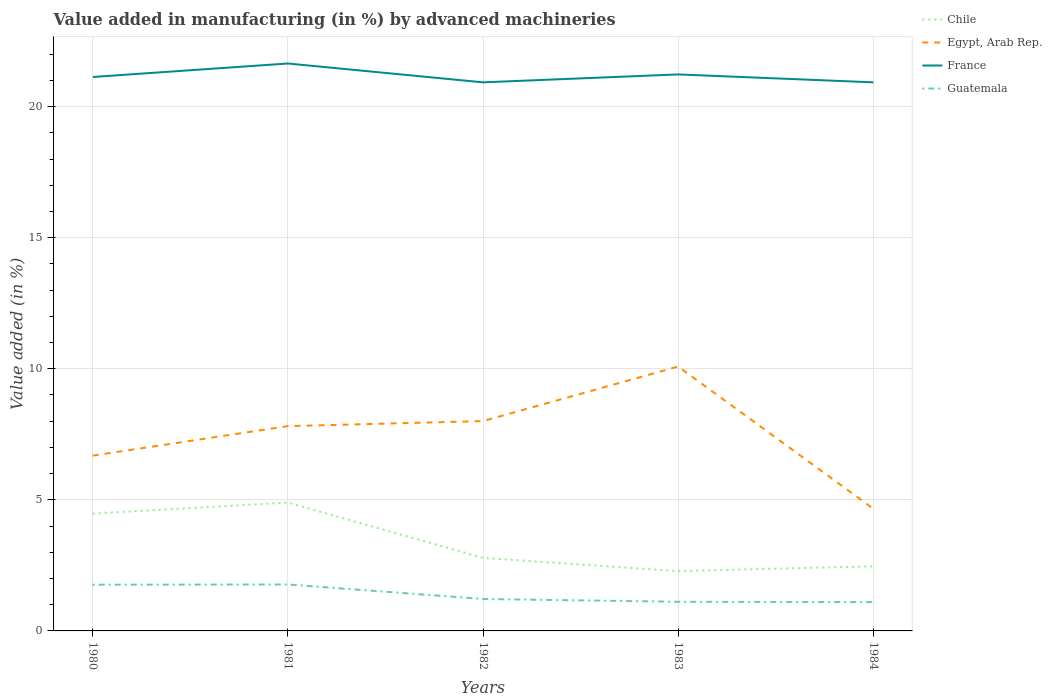How many different coloured lines are there?
Give a very brief answer. 4. Is the number of lines equal to the number of legend labels?
Give a very brief answer. Yes. Across all years, what is the maximum percentage of value added in manufacturing by advanced machineries in Guatemala?
Provide a short and direct response. 1.1. What is the total percentage of value added in manufacturing by advanced machineries in Chile in the graph?
Give a very brief answer. 0.32. What is the difference between the highest and the second highest percentage of value added in manufacturing by advanced machineries in Chile?
Provide a succinct answer. 2.61. How many years are there in the graph?
Give a very brief answer. 5. What is the difference between two consecutive major ticks on the Y-axis?
Keep it short and to the point. 5. Does the graph contain grids?
Your answer should be compact. Yes. How are the legend labels stacked?
Your response must be concise. Vertical. What is the title of the graph?
Your answer should be very brief. Value added in manufacturing (in %) by advanced machineries. What is the label or title of the Y-axis?
Offer a very short reply. Value added (in %). What is the Value added (in %) of Chile in 1980?
Offer a terse response. 4.48. What is the Value added (in %) in Egypt, Arab Rep. in 1980?
Your answer should be very brief. 6.69. What is the Value added (in %) in France in 1980?
Your response must be concise. 21.13. What is the Value added (in %) in Guatemala in 1980?
Give a very brief answer. 1.76. What is the Value added (in %) in Chile in 1981?
Make the answer very short. 4.9. What is the Value added (in %) of Egypt, Arab Rep. in 1981?
Your response must be concise. 7.81. What is the Value added (in %) in France in 1981?
Give a very brief answer. 21.64. What is the Value added (in %) in Guatemala in 1981?
Your response must be concise. 1.77. What is the Value added (in %) of Chile in 1982?
Offer a very short reply. 2.79. What is the Value added (in %) of Egypt, Arab Rep. in 1982?
Make the answer very short. 8. What is the Value added (in %) in France in 1982?
Provide a succinct answer. 20.93. What is the Value added (in %) of Guatemala in 1982?
Make the answer very short. 1.22. What is the Value added (in %) of Chile in 1983?
Your response must be concise. 2.28. What is the Value added (in %) in Egypt, Arab Rep. in 1983?
Make the answer very short. 10.09. What is the Value added (in %) of France in 1983?
Your answer should be very brief. 21.23. What is the Value added (in %) of Guatemala in 1983?
Offer a very short reply. 1.11. What is the Value added (in %) of Chile in 1984?
Give a very brief answer. 2.47. What is the Value added (in %) of Egypt, Arab Rep. in 1984?
Provide a short and direct response. 4.66. What is the Value added (in %) in France in 1984?
Offer a terse response. 20.93. What is the Value added (in %) of Guatemala in 1984?
Keep it short and to the point. 1.1. Across all years, what is the maximum Value added (in %) in Chile?
Your response must be concise. 4.9. Across all years, what is the maximum Value added (in %) of Egypt, Arab Rep.?
Make the answer very short. 10.09. Across all years, what is the maximum Value added (in %) of France?
Provide a short and direct response. 21.64. Across all years, what is the maximum Value added (in %) in Guatemala?
Ensure brevity in your answer.  1.77. Across all years, what is the minimum Value added (in %) of Chile?
Your answer should be compact. 2.28. Across all years, what is the minimum Value added (in %) in Egypt, Arab Rep.?
Make the answer very short. 4.66. Across all years, what is the minimum Value added (in %) of France?
Provide a short and direct response. 20.93. Across all years, what is the minimum Value added (in %) of Guatemala?
Ensure brevity in your answer.  1.1. What is the total Value added (in %) of Chile in the graph?
Offer a terse response. 16.9. What is the total Value added (in %) of Egypt, Arab Rep. in the graph?
Keep it short and to the point. 37.25. What is the total Value added (in %) in France in the graph?
Offer a very short reply. 105.86. What is the total Value added (in %) in Guatemala in the graph?
Make the answer very short. 6.96. What is the difference between the Value added (in %) of Chile in 1980 and that in 1981?
Your answer should be very brief. -0.42. What is the difference between the Value added (in %) in Egypt, Arab Rep. in 1980 and that in 1981?
Offer a very short reply. -1.12. What is the difference between the Value added (in %) in France in 1980 and that in 1981?
Keep it short and to the point. -0.51. What is the difference between the Value added (in %) of Guatemala in 1980 and that in 1981?
Offer a terse response. -0.01. What is the difference between the Value added (in %) in Chile in 1980 and that in 1982?
Keep it short and to the point. 1.69. What is the difference between the Value added (in %) of Egypt, Arab Rep. in 1980 and that in 1982?
Provide a succinct answer. -1.32. What is the difference between the Value added (in %) in France in 1980 and that in 1982?
Provide a succinct answer. 0.2. What is the difference between the Value added (in %) in Guatemala in 1980 and that in 1982?
Make the answer very short. 0.54. What is the difference between the Value added (in %) of Chile in 1980 and that in 1983?
Your answer should be very brief. 2.19. What is the difference between the Value added (in %) in Egypt, Arab Rep. in 1980 and that in 1983?
Provide a short and direct response. -3.4. What is the difference between the Value added (in %) of France in 1980 and that in 1983?
Keep it short and to the point. -0.1. What is the difference between the Value added (in %) in Guatemala in 1980 and that in 1983?
Your answer should be compact. 0.65. What is the difference between the Value added (in %) in Chile in 1980 and that in 1984?
Your response must be concise. 2.01. What is the difference between the Value added (in %) in Egypt, Arab Rep. in 1980 and that in 1984?
Give a very brief answer. 2.02. What is the difference between the Value added (in %) in France in 1980 and that in 1984?
Your response must be concise. 0.2. What is the difference between the Value added (in %) in Guatemala in 1980 and that in 1984?
Your response must be concise. 0.66. What is the difference between the Value added (in %) in Chile in 1981 and that in 1982?
Your answer should be compact. 2.11. What is the difference between the Value added (in %) of Egypt, Arab Rep. in 1981 and that in 1982?
Provide a succinct answer. -0.19. What is the difference between the Value added (in %) of France in 1981 and that in 1982?
Your response must be concise. 0.72. What is the difference between the Value added (in %) of Guatemala in 1981 and that in 1982?
Keep it short and to the point. 0.55. What is the difference between the Value added (in %) in Chile in 1981 and that in 1983?
Ensure brevity in your answer.  2.61. What is the difference between the Value added (in %) in Egypt, Arab Rep. in 1981 and that in 1983?
Give a very brief answer. -2.27. What is the difference between the Value added (in %) of France in 1981 and that in 1983?
Provide a short and direct response. 0.42. What is the difference between the Value added (in %) of Guatemala in 1981 and that in 1983?
Make the answer very short. 0.66. What is the difference between the Value added (in %) of Chile in 1981 and that in 1984?
Your response must be concise. 2.43. What is the difference between the Value added (in %) in Egypt, Arab Rep. in 1981 and that in 1984?
Give a very brief answer. 3.15. What is the difference between the Value added (in %) in France in 1981 and that in 1984?
Your answer should be very brief. 0.72. What is the difference between the Value added (in %) of Guatemala in 1981 and that in 1984?
Your answer should be very brief. 0.67. What is the difference between the Value added (in %) of Chile in 1982 and that in 1983?
Your answer should be compact. 0.51. What is the difference between the Value added (in %) in Egypt, Arab Rep. in 1982 and that in 1983?
Offer a terse response. -2.08. What is the difference between the Value added (in %) of France in 1982 and that in 1983?
Your response must be concise. -0.3. What is the difference between the Value added (in %) in Guatemala in 1982 and that in 1983?
Keep it short and to the point. 0.11. What is the difference between the Value added (in %) of Chile in 1982 and that in 1984?
Provide a succinct answer. 0.32. What is the difference between the Value added (in %) of Egypt, Arab Rep. in 1982 and that in 1984?
Give a very brief answer. 3.34. What is the difference between the Value added (in %) in France in 1982 and that in 1984?
Make the answer very short. -0. What is the difference between the Value added (in %) in Guatemala in 1982 and that in 1984?
Make the answer very short. 0.12. What is the difference between the Value added (in %) in Chile in 1983 and that in 1984?
Keep it short and to the point. -0.18. What is the difference between the Value added (in %) in Egypt, Arab Rep. in 1983 and that in 1984?
Offer a very short reply. 5.42. What is the difference between the Value added (in %) in France in 1983 and that in 1984?
Give a very brief answer. 0.3. What is the difference between the Value added (in %) of Guatemala in 1983 and that in 1984?
Provide a short and direct response. 0.01. What is the difference between the Value added (in %) in Chile in 1980 and the Value added (in %) in Egypt, Arab Rep. in 1981?
Ensure brevity in your answer.  -3.34. What is the difference between the Value added (in %) of Chile in 1980 and the Value added (in %) of France in 1981?
Your answer should be very brief. -17.17. What is the difference between the Value added (in %) of Chile in 1980 and the Value added (in %) of Guatemala in 1981?
Your answer should be very brief. 2.7. What is the difference between the Value added (in %) in Egypt, Arab Rep. in 1980 and the Value added (in %) in France in 1981?
Offer a terse response. -14.96. What is the difference between the Value added (in %) in Egypt, Arab Rep. in 1980 and the Value added (in %) in Guatemala in 1981?
Ensure brevity in your answer.  4.92. What is the difference between the Value added (in %) in France in 1980 and the Value added (in %) in Guatemala in 1981?
Your response must be concise. 19.36. What is the difference between the Value added (in %) of Chile in 1980 and the Value added (in %) of Egypt, Arab Rep. in 1982?
Your answer should be compact. -3.53. What is the difference between the Value added (in %) of Chile in 1980 and the Value added (in %) of France in 1982?
Your response must be concise. -16.45. What is the difference between the Value added (in %) of Chile in 1980 and the Value added (in %) of Guatemala in 1982?
Ensure brevity in your answer.  3.26. What is the difference between the Value added (in %) in Egypt, Arab Rep. in 1980 and the Value added (in %) in France in 1982?
Your answer should be compact. -14.24. What is the difference between the Value added (in %) in Egypt, Arab Rep. in 1980 and the Value added (in %) in Guatemala in 1982?
Give a very brief answer. 5.47. What is the difference between the Value added (in %) of France in 1980 and the Value added (in %) of Guatemala in 1982?
Offer a terse response. 19.91. What is the difference between the Value added (in %) in Chile in 1980 and the Value added (in %) in Egypt, Arab Rep. in 1983?
Your response must be concise. -5.61. What is the difference between the Value added (in %) in Chile in 1980 and the Value added (in %) in France in 1983?
Give a very brief answer. -16.75. What is the difference between the Value added (in %) in Chile in 1980 and the Value added (in %) in Guatemala in 1983?
Offer a very short reply. 3.36. What is the difference between the Value added (in %) in Egypt, Arab Rep. in 1980 and the Value added (in %) in France in 1983?
Offer a terse response. -14.54. What is the difference between the Value added (in %) in Egypt, Arab Rep. in 1980 and the Value added (in %) in Guatemala in 1983?
Give a very brief answer. 5.58. What is the difference between the Value added (in %) in France in 1980 and the Value added (in %) in Guatemala in 1983?
Ensure brevity in your answer.  20.02. What is the difference between the Value added (in %) in Chile in 1980 and the Value added (in %) in Egypt, Arab Rep. in 1984?
Make the answer very short. -0.19. What is the difference between the Value added (in %) of Chile in 1980 and the Value added (in %) of France in 1984?
Provide a succinct answer. -16.45. What is the difference between the Value added (in %) of Chile in 1980 and the Value added (in %) of Guatemala in 1984?
Ensure brevity in your answer.  3.38. What is the difference between the Value added (in %) in Egypt, Arab Rep. in 1980 and the Value added (in %) in France in 1984?
Offer a terse response. -14.24. What is the difference between the Value added (in %) of Egypt, Arab Rep. in 1980 and the Value added (in %) of Guatemala in 1984?
Your answer should be very brief. 5.59. What is the difference between the Value added (in %) in France in 1980 and the Value added (in %) in Guatemala in 1984?
Your response must be concise. 20.03. What is the difference between the Value added (in %) of Chile in 1981 and the Value added (in %) of Egypt, Arab Rep. in 1982?
Your response must be concise. -3.11. What is the difference between the Value added (in %) in Chile in 1981 and the Value added (in %) in France in 1982?
Keep it short and to the point. -16.03. What is the difference between the Value added (in %) in Chile in 1981 and the Value added (in %) in Guatemala in 1982?
Your answer should be very brief. 3.68. What is the difference between the Value added (in %) of Egypt, Arab Rep. in 1981 and the Value added (in %) of France in 1982?
Provide a short and direct response. -13.11. What is the difference between the Value added (in %) of Egypt, Arab Rep. in 1981 and the Value added (in %) of Guatemala in 1982?
Your answer should be compact. 6.59. What is the difference between the Value added (in %) in France in 1981 and the Value added (in %) in Guatemala in 1982?
Make the answer very short. 20.43. What is the difference between the Value added (in %) in Chile in 1981 and the Value added (in %) in Egypt, Arab Rep. in 1983?
Provide a succinct answer. -5.19. What is the difference between the Value added (in %) of Chile in 1981 and the Value added (in %) of France in 1983?
Keep it short and to the point. -16.33. What is the difference between the Value added (in %) in Chile in 1981 and the Value added (in %) in Guatemala in 1983?
Give a very brief answer. 3.78. What is the difference between the Value added (in %) of Egypt, Arab Rep. in 1981 and the Value added (in %) of France in 1983?
Your answer should be very brief. -13.42. What is the difference between the Value added (in %) in Egypt, Arab Rep. in 1981 and the Value added (in %) in Guatemala in 1983?
Offer a very short reply. 6.7. What is the difference between the Value added (in %) of France in 1981 and the Value added (in %) of Guatemala in 1983?
Your answer should be compact. 20.53. What is the difference between the Value added (in %) of Chile in 1981 and the Value added (in %) of Egypt, Arab Rep. in 1984?
Your answer should be very brief. 0.23. What is the difference between the Value added (in %) in Chile in 1981 and the Value added (in %) in France in 1984?
Offer a terse response. -16.03. What is the difference between the Value added (in %) in Chile in 1981 and the Value added (in %) in Guatemala in 1984?
Your answer should be compact. 3.8. What is the difference between the Value added (in %) in Egypt, Arab Rep. in 1981 and the Value added (in %) in France in 1984?
Your response must be concise. -13.11. What is the difference between the Value added (in %) of Egypt, Arab Rep. in 1981 and the Value added (in %) of Guatemala in 1984?
Give a very brief answer. 6.71. What is the difference between the Value added (in %) in France in 1981 and the Value added (in %) in Guatemala in 1984?
Provide a short and direct response. 20.55. What is the difference between the Value added (in %) of Chile in 1982 and the Value added (in %) of Egypt, Arab Rep. in 1983?
Provide a short and direct response. -7.3. What is the difference between the Value added (in %) of Chile in 1982 and the Value added (in %) of France in 1983?
Your answer should be compact. -18.44. What is the difference between the Value added (in %) in Chile in 1982 and the Value added (in %) in Guatemala in 1983?
Offer a terse response. 1.67. What is the difference between the Value added (in %) of Egypt, Arab Rep. in 1982 and the Value added (in %) of France in 1983?
Your response must be concise. -13.22. What is the difference between the Value added (in %) in Egypt, Arab Rep. in 1982 and the Value added (in %) in Guatemala in 1983?
Offer a terse response. 6.89. What is the difference between the Value added (in %) of France in 1982 and the Value added (in %) of Guatemala in 1983?
Ensure brevity in your answer.  19.81. What is the difference between the Value added (in %) in Chile in 1982 and the Value added (in %) in Egypt, Arab Rep. in 1984?
Give a very brief answer. -1.88. What is the difference between the Value added (in %) of Chile in 1982 and the Value added (in %) of France in 1984?
Your answer should be very brief. -18.14. What is the difference between the Value added (in %) of Chile in 1982 and the Value added (in %) of Guatemala in 1984?
Your answer should be compact. 1.69. What is the difference between the Value added (in %) of Egypt, Arab Rep. in 1982 and the Value added (in %) of France in 1984?
Your answer should be compact. -12.92. What is the difference between the Value added (in %) in Egypt, Arab Rep. in 1982 and the Value added (in %) in Guatemala in 1984?
Offer a terse response. 6.9. What is the difference between the Value added (in %) of France in 1982 and the Value added (in %) of Guatemala in 1984?
Give a very brief answer. 19.83. What is the difference between the Value added (in %) in Chile in 1983 and the Value added (in %) in Egypt, Arab Rep. in 1984?
Ensure brevity in your answer.  -2.38. What is the difference between the Value added (in %) in Chile in 1983 and the Value added (in %) in France in 1984?
Make the answer very short. -18.65. What is the difference between the Value added (in %) in Chile in 1983 and the Value added (in %) in Guatemala in 1984?
Your response must be concise. 1.18. What is the difference between the Value added (in %) of Egypt, Arab Rep. in 1983 and the Value added (in %) of France in 1984?
Ensure brevity in your answer.  -10.84. What is the difference between the Value added (in %) in Egypt, Arab Rep. in 1983 and the Value added (in %) in Guatemala in 1984?
Ensure brevity in your answer.  8.99. What is the difference between the Value added (in %) of France in 1983 and the Value added (in %) of Guatemala in 1984?
Offer a very short reply. 20.13. What is the average Value added (in %) of Chile per year?
Keep it short and to the point. 3.38. What is the average Value added (in %) in Egypt, Arab Rep. per year?
Ensure brevity in your answer.  7.45. What is the average Value added (in %) of France per year?
Make the answer very short. 21.17. What is the average Value added (in %) of Guatemala per year?
Your answer should be compact. 1.39. In the year 1980, what is the difference between the Value added (in %) of Chile and Value added (in %) of Egypt, Arab Rep.?
Make the answer very short. -2.21. In the year 1980, what is the difference between the Value added (in %) of Chile and Value added (in %) of France?
Provide a succinct answer. -16.66. In the year 1980, what is the difference between the Value added (in %) of Chile and Value added (in %) of Guatemala?
Offer a very short reply. 2.71. In the year 1980, what is the difference between the Value added (in %) in Egypt, Arab Rep. and Value added (in %) in France?
Offer a terse response. -14.44. In the year 1980, what is the difference between the Value added (in %) of Egypt, Arab Rep. and Value added (in %) of Guatemala?
Make the answer very short. 4.92. In the year 1980, what is the difference between the Value added (in %) of France and Value added (in %) of Guatemala?
Offer a very short reply. 19.37. In the year 1981, what is the difference between the Value added (in %) of Chile and Value added (in %) of Egypt, Arab Rep.?
Your response must be concise. -2.92. In the year 1981, what is the difference between the Value added (in %) in Chile and Value added (in %) in France?
Provide a short and direct response. -16.75. In the year 1981, what is the difference between the Value added (in %) in Chile and Value added (in %) in Guatemala?
Make the answer very short. 3.12. In the year 1981, what is the difference between the Value added (in %) in Egypt, Arab Rep. and Value added (in %) in France?
Provide a short and direct response. -13.83. In the year 1981, what is the difference between the Value added (in %) in Egypt, Arab Rep. and Value added (in %) in Guatemala?
Your answer should be compact. 6.04. In the year 1981, what is the difference between the Value added (in %) in France and Value added (in %) in Guatemala?
Your answer should be very brief. 19.87. In the year 1982, what is the difference between the Value added (in %) in Chile and Value added (in %) in Egypt, Arab Rep.?
Offer a terse response. -5.22. In the year 1982, what is the difference between the Value added (in %) of Chile and Value added (in %) of France?
Ensure brevity in your answer.  -18.14. In the year 1982, what is the difference between the Value added (in %) of Chile and Value added (in %) of Guatemala?
Give a very brief answer. 1.57. In the year 1982, what is the difference between the Value added (in %) of Egypt, Arab Rep. and Value added (in %) of France?
Provide a succinct answer. -12.92. In the year 1982, what is the difference between the Value added (in %) in Egypt, Arab Rep. and Value added (in %) in Guatemala?
Your answer should be very brief. 6.79. In the year 1982, what is the difference between the Value added (in %) in France and Value added (in %) in Guatemala?
Keep it short and to the point. 19.71. In the year 1983, what is the difference between the Value added (in %) in Chile and Value added (in %) in Egypt, Arab Rep.?
Provide a succinct answer. -7.8. In the year 1983, what is the difference between the Value added (in %) in Chile and Value added (in %) in France?
Keep it short and to the point. -18.95. In the year 1983, what is the difference between the Value added (in %) of Chile and Value added (in %) of Guatemala?
Your answer should be very brief. 1.17. In the year 1983, what is the difference between the Value added (in %) in Egypt, Arab Rep. and Value added (in %) in France?
Ensure brevity in your answer.  -11.14. In the year 1983, what is the difference between the Value added (in %) in Egypt, Arab Rep. and Value added (in %) in Guatemala?
Make the answer very short. 8.97. In the year 1983, what is the difference between the Value added (in %) of France and Value added (in %) of Guatemala?
Keep it short and to the point. 20.12. In the year 1984, what is the difference between the Value added (in %) in Chile and Value added (in %) in Egypt, Arab Rep.?
Offer a terse response. -2.2. In the year 1984, what is the difference between the Value added (in %) in Chile and Value added (in %) in France?
Make the answer very short. -18.46. In the year 1984, what is the difference between the Value added (in %) in Chile and Value added (in %) in Guatemala?
Your answer should be very brief. 1.37. In the year 1984, what is the difference between the Value added (in %) in Egypt, Arab Rep. and Value added (in %) in France?
Give a very brief answer. -16.26. In the year 1984, what is the difference between the Value added (in %) of Egypt, Arab Rep. and Value added (in %) of Guatemala?
Provide a succinct answer. 3.56. In the year 1984, what is the difference between the Value added (in %) in France and Value added (in %) in Guatemala?
Provide a succinct answer. 19.83. What is the ratio of the Value added (in %) in Chile in 1980 to that in 1981?
Keep it short and to the point. 0.91. What is the ratio of the Value added (in %) of Egypt, Arab Rep. in 1980 to that in 1981?
Your response must be concise. 0.86. What is the ratio of the Value added (in %) of France in 1980 to that in 1981?
Offer a terse response. 0.98. What is the ratio of the Value added (in %) of Chile in 1980 to that in 1982?
Give a very brief answer. 1.61. What is the ratio of the Value added (in %) in Egypt, Arab Rep. in 1980 to that in 1982?
Your answer should be very brief. 0.84. What is the ratio of the Value added (in %) of France in 1980 to that in 1982?
Make the answer very short. 1.01. What is the ratio of the Value added (in %) of Guatemala in 1980 to that in 1982?
Your answer should be very brief. 1.45. What is the ratio of the Value added (in %) of Chile in 1980 to that in 1983?
Your answer should be very brief. 1.96. What is the ratio of the Value added (in %) in Egypt, Arab Rep. in 1980 to that in 1983?
Keep it short and to the point. 0.66. What is the ratio of the Value added (in %) in France in 1980 to that in 1983?
Offer a terse response. 1. What is the ratio of the Value added (in %) in Guatemala in 1980 to that in 1983?
Offer a terse response. 1.58. What is the ratio of the Value added (in %) of Chile in 1980 to that in 1984?
Provide a short and direct response. 1.82. What is the ratio of the Value added (in %) in Egypt, Arab Rep. in 1980 to that in 1984?
Ensure brevity in your answer.  1.43. What is the ratio of the Value added (in %) in France in 1980 to that in 1984?
Provide a short and direct response. 1.01. What is the ratio of the Value added (in %) in Guatemala in 1980 to that in 1984?
Provide a short and direct response. 1.6. What is the ratio of the Value added (in %) in Chile in 1981 to that in 1982?
Give a very brief answer. 1.76. What is the ratio of the Value added (in %) in Egypt, Arab Rep. in 1981 to that in 1982?
Offer a very short reply. 0.98. What is the ratio of the Value added (in %) in France in 1981 to that in 1982?
Keep it short and to the point. 1.03. What is the ratio of the Value added (in %) in Guatemala in 1981 to that in 1982?
Provide a short and direct response. 1.45. What is the ratio of the Value added (in %) in Chile in 1981 to that in 1983?
Your answer should be very brief. 2.15. What is the ratio of the Value added (in %) in Egypt, Arab Rep. in 1981 to that in 1983?
Give a very brief answer. 0.77. What is the ratio of the Value added (in %) of France in 1981 to that in 1983?
Provide a short and direct response. 1.02. What is the ratio of the Value added (in %) of Guatemala in 1981 to that in 1983?
Offer a terse response. 1.59. What is the ratio of the Value added (in %) of Chile in 1981 to that in 1984?
Ensure brevity in your answer.  1.99. What is the ratio of the Value added (in %) in Egypt, Arab Rep. in 1981 to that in 1984?
Your answer should be compact. 1.68. What is the ratio of the Value added (in %) of France in 1981 to that in 1984?
Offer a terse response. 1.03. What is the ratio of the Value added (in %) in Guatemala in 1981 to that in 1984?
Ensure brevity in your answer.  1.61. What is the ratio of the Value added (in %) in Chile in 1982 to that in 1983?
Provide a short and direct response. 1.22. What is the ratio of the Value added (in %) of Egypt, Arab Rep. in 1982 to that in 1983?
Provide a short and direct response. 0.79. What is the ratio of the Value added (in %) in France in 1982 to that in 1983?
Give a very brief answer. 0.99. What is the ratio of the Value added (in %) in Guatemala in 1982 to that in 1983?
Offer a very short reply. 1.1. What is the ratio of the Value added (in %) in Chile in 1982 to that in 1984?
Offer a very short reply. 1.13. What is the ratio of the Value added (in %) in Egypt, Arab Rep. in 1982 to that in 1984?
Your answer should be very brief. 1.72. What is the ratio of the Value added (in %) in Guatemala in 1982 to that in 1984?
Your answer should be compact. 1.11. What is the ratio of the Value added (in %) in Chile in 1983 to that in 1984?
Make the answer very short. 0.93. What is the ratio of the Value added (in %) of Egypt, Arab Rep. in 1983 to that in 1984?
Provide a succinct answer. 2.16. What is the ratio of the Value added (in %) of France in 1983 to that in 1984?
Keep it short and to the point. 1.01. What is the ratio of the Value added (in %) of Guatemala in 1983 to that in 1984?
Provide a succinct answer. 1.01. What is the difference between the highest and the second highest Value added (in %) in Chile?
Provide a succinct answer. 0.42. What is the difference between the highest and the second highest Value added (in %) of Egypt, Arab Rep.?
Offer a terse response. 2.08. What is the difference between the highest and the second highest Value added (in %) of France?
Provide a succinct answer. 0.42. What is the difference between the highest and the second highest Value added (in %) in Guatemala?
Your answer should be very brief. 0.01. What is the difference between the highest and the lowest Value added (in %) of Chile?
Give a very brief answer. 2.61. What is the difference between the highest and the lowest Value added (in %) of Egypt, Arab Rep.?
Make the answer very short. 5.42. What is the difference between the highest and the lowest Value added (in %) in France?
Keep it short and to the point. 0.72. What is the difference between the highest and the lowest Value added (in %) in Guatemala?
Provide a short and direct response. 0.67. 